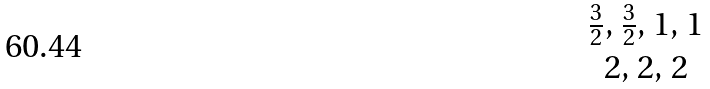Convert formula to latex. <formula><loc_0><loc_0><loc_500><loc_500>\begin{matrix} \frac { 3 } { 2 } , \, \frac { 3 } { 2 } , \, 1 , \, 1 \\ 2 , \, 2 , \, 2 \end{matrix}</formula> 